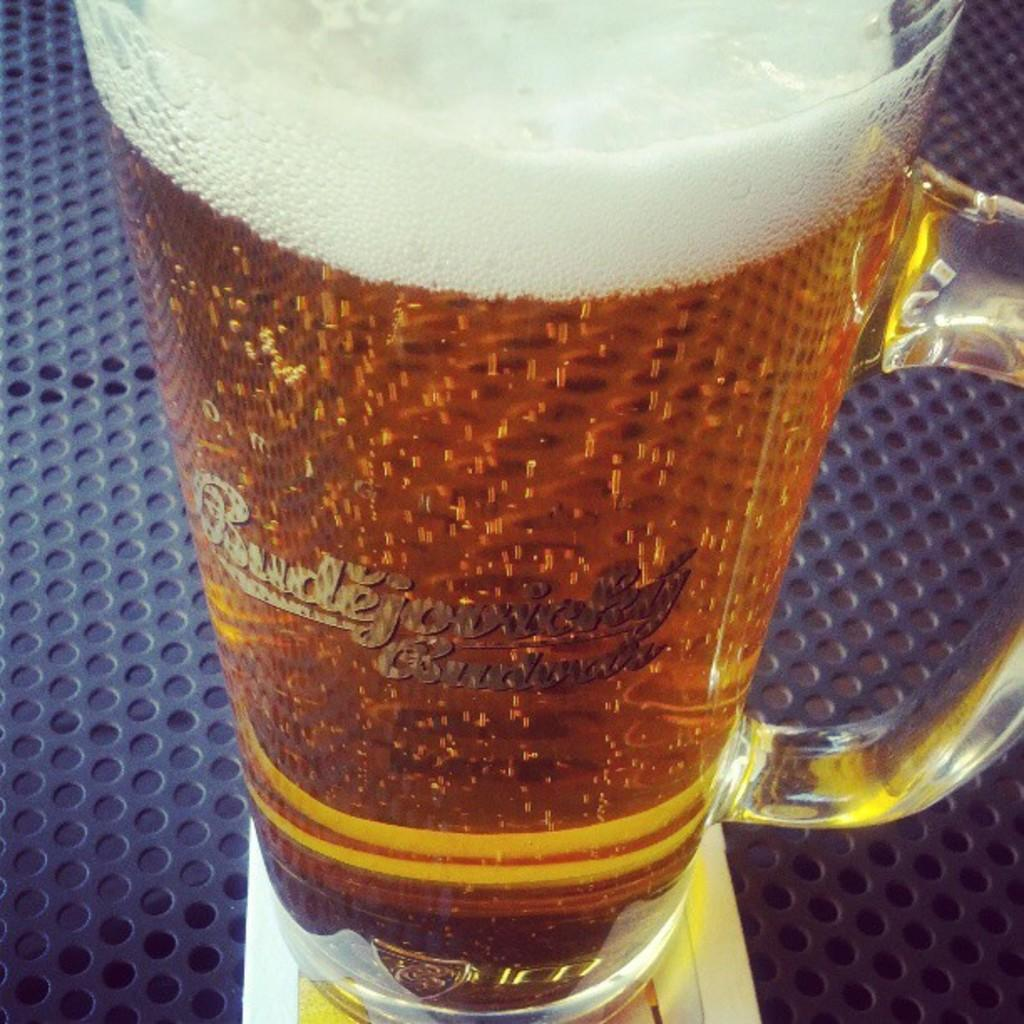Provide a one-sentence caption for the provided image. On a metal surface painted blue and full of holes sits a tall mug of Budejovicky. 